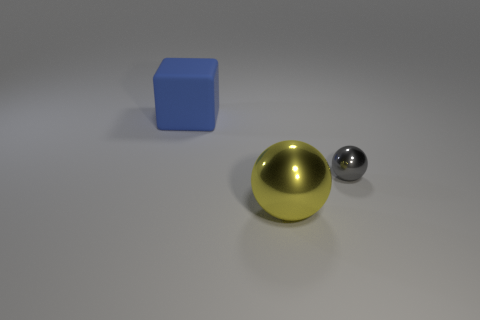Subtract 1 yellow spheres. How many objects are left? 2 Subtract all balls. How many objects are left? 1 Subtract 1 spheres. How many spheres are left? 1 Subtract all yellow cubes. Subtract all yellow cylinders. How many cubes are left? 1 Subtract all red cylinders. How many cyan balls are left? 0 Subtract all blue rubber cubes. Subtract all cylinders. How many objects are left? 2 Add 2 blue objects. How many blue objects are left? 3 Add 2 blue rubber blocks. How many blue rubber blocks exist? 3 Add 3 blue blocks. How many objects exist? 6 Subtract all yellow balls. How many balls are left? 1 